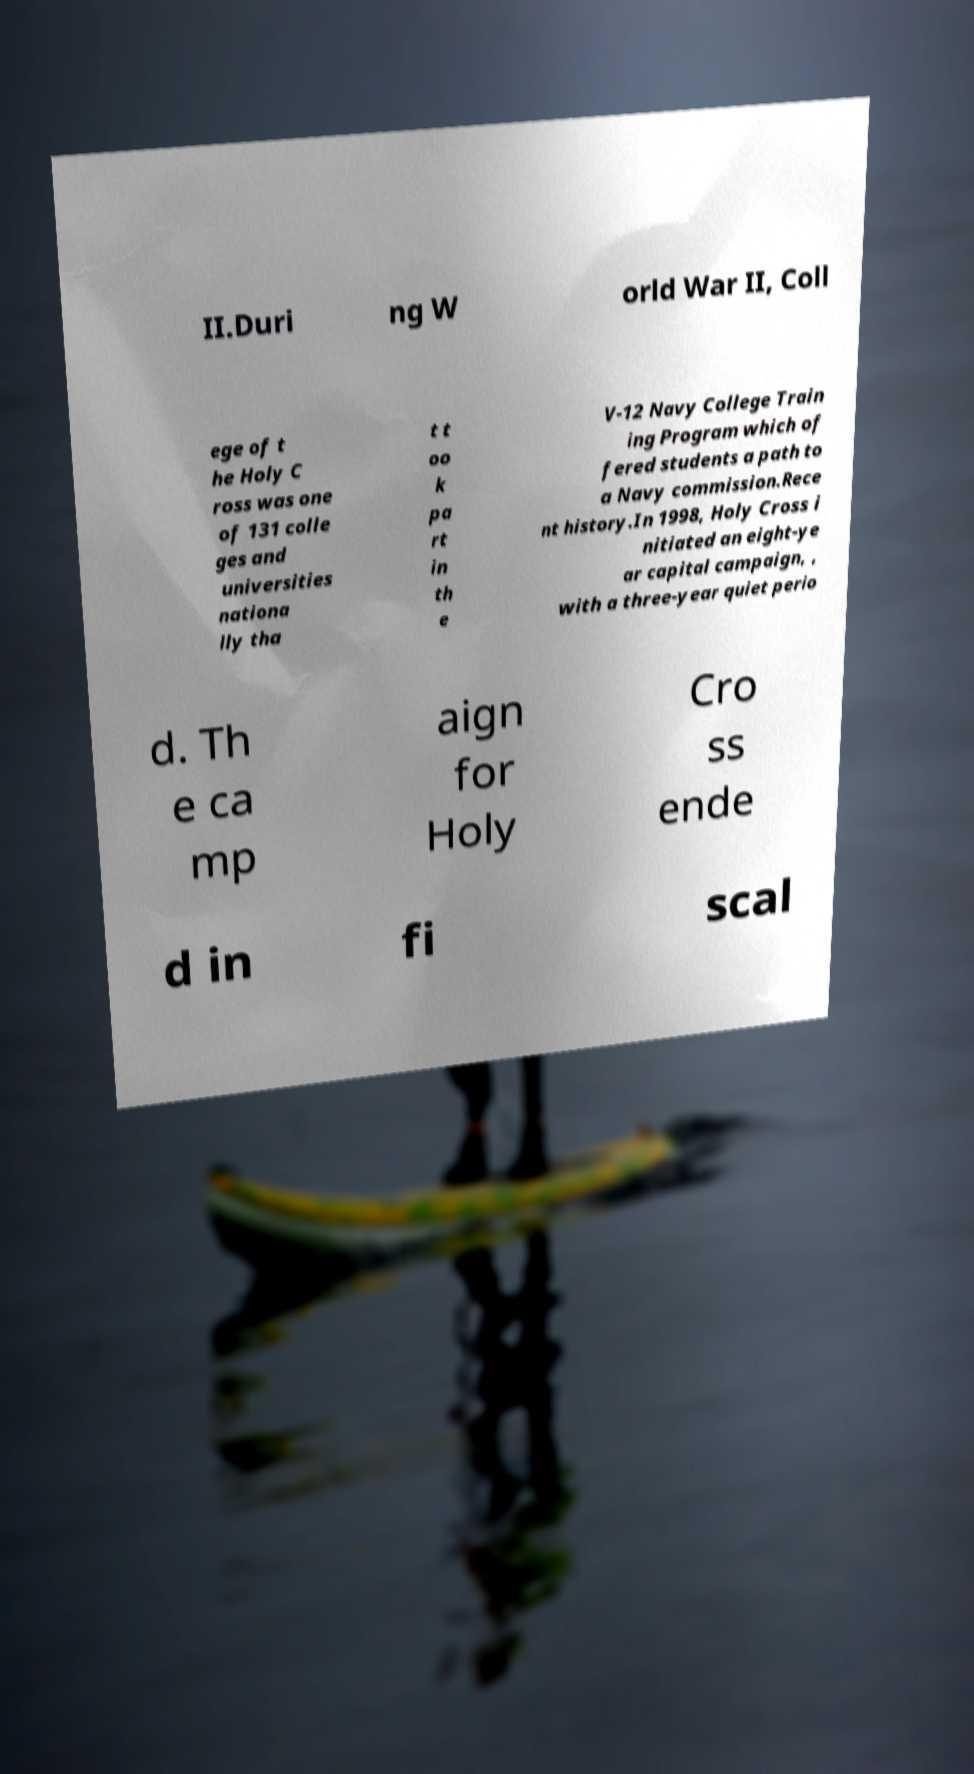Please identify and transcribe the text found in this image. II.Duri ng W orld War II, Coll ege of t he Holy C ross was one of 131 colle ges and universities nationa lly tha t t oo k pa rt in th e V-12 Navy College Train ing Program which of fered students a path to a Navy commission.Rece nt history.In 1998, Holy Cross i nitiated an eight-ye ar capital campaign, , with a three-year quiet perio d. Th e ca mp aign for Holy Cro ss ende d in fi scal 